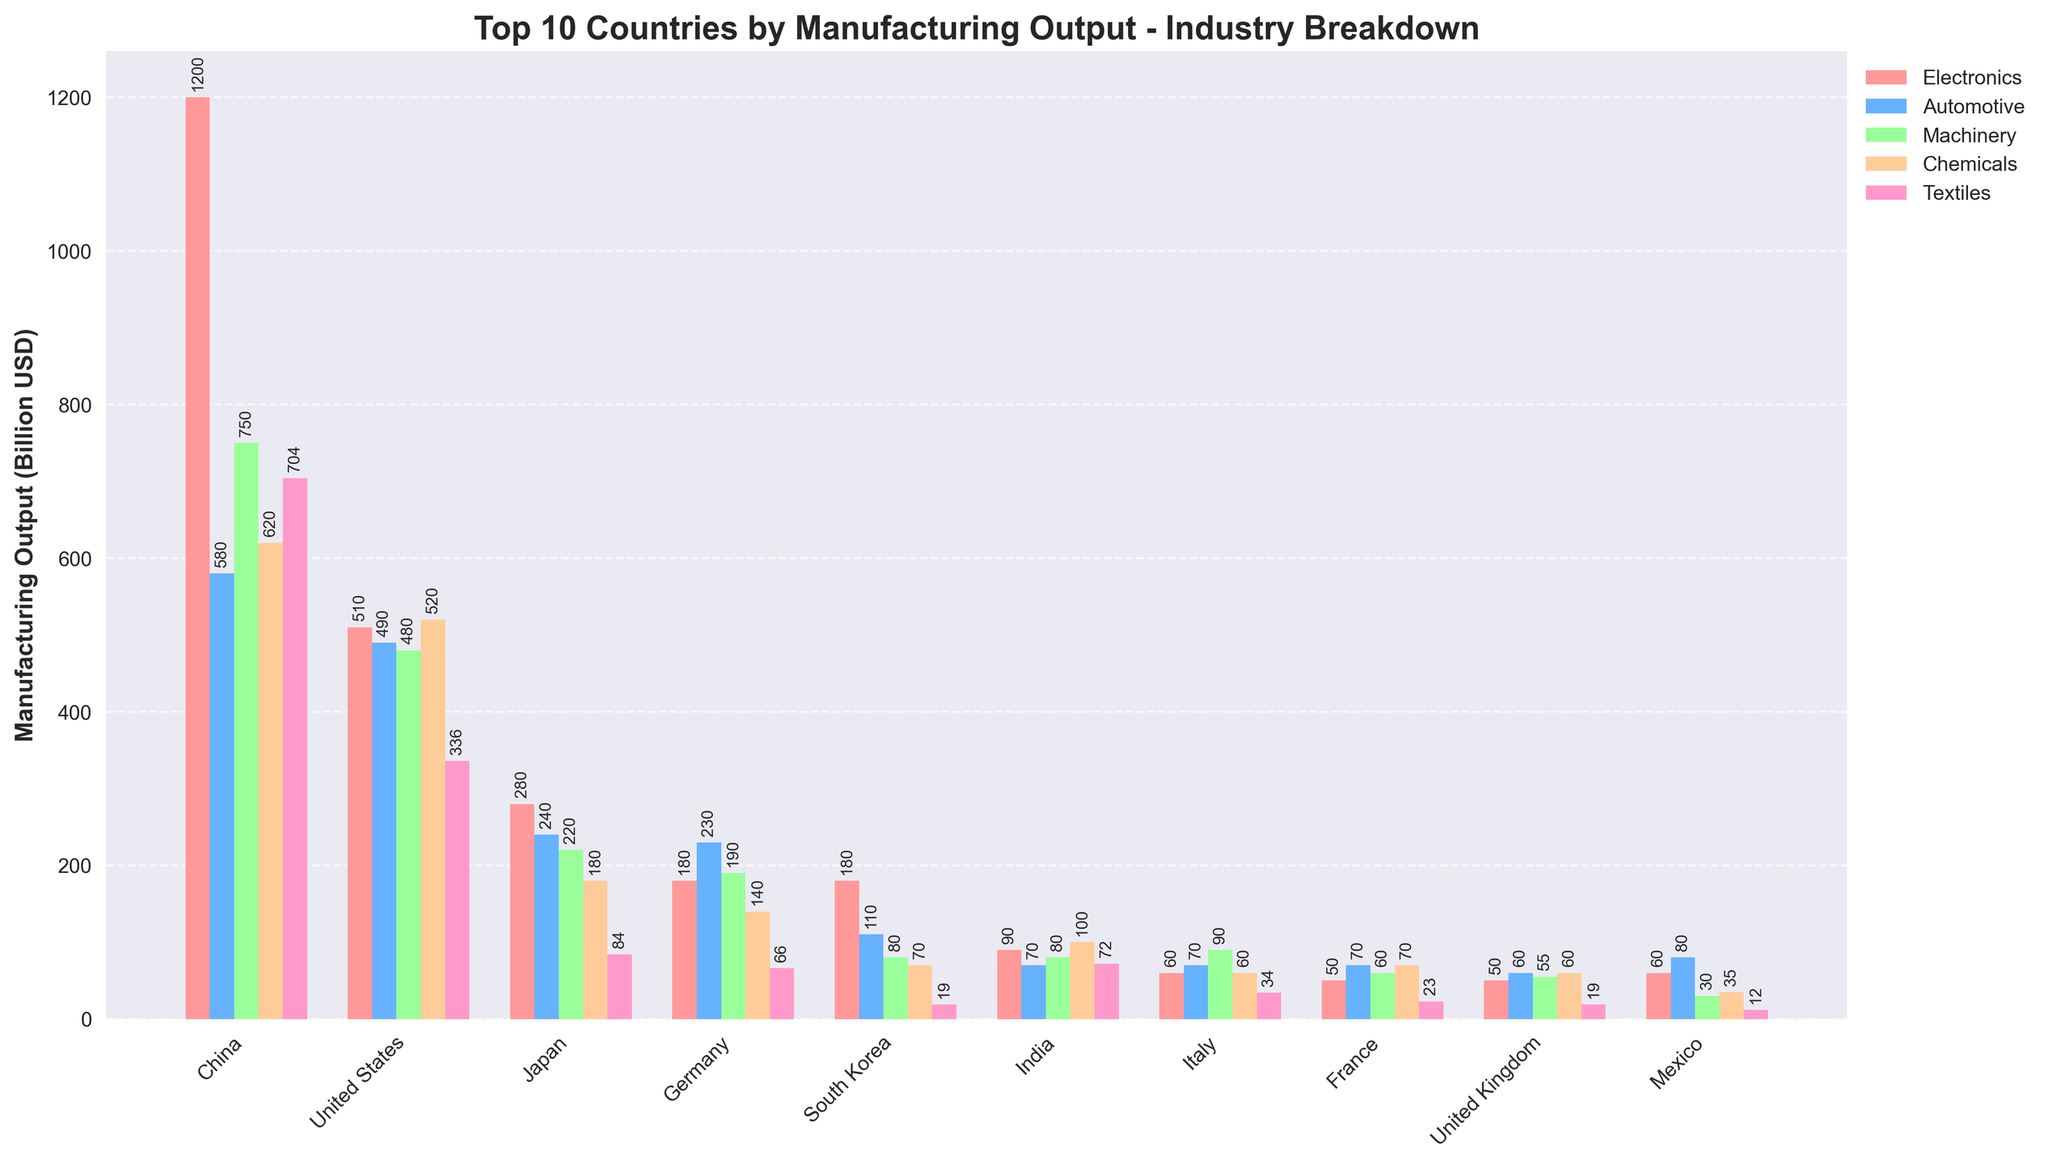What's the total manufacturing output of Japan in the Automotive and Machinery sectors combined? To find the total manufacturing output of Japan in the Automotive and Machinery sectors, add the values for Automotive (240 Billion USD) and Machinery (220 Billion USD). 240 + 220 = 460 Billion USD.
Answer: 460 Billion USD Which country has the highest manufacturing output in the Electronics sector? By examining the height of the bars in the Electronics sector for all countries, China has the highest bar with an output of 1200 Billion USD.
Answer: China How does the manufacturing output of Chemicals in Germany compare to that in France? Look at the bars for the Chemicals sector in Germany and France. Germany's bar is taller, indicating a higher manufacturing output. Germany’s output is 140 Billion USD, while France’s output is 70 Billion USD. 140 - 70 = 70 Billion USD, so Germany produces 70 Billion USD more in Chemicals than France.
Answer: Germany is 70 Billion USD higher What is the average manufacturing output in the Textiles sector across the top 10 countries? Sum the manufacturing outputs in Textiles for all countries: 704 (China) + 336 (USA) + 84 (Japan) + 66 (Germany) + 19 (South Korea) + 72 (India) + 34 (Italy) + 23 (France) + 19 (UK) + 12 (Mexico) = 1369 Billion USD. There are 10 countries; therefore, the average is 1369 / 10 = 136.9 Billion USD.
Answer: 136.9 Billion USD Which country has the lowest total manufacturing output, and what is that number? By inspecting the total height of all bars aggregated for each country, Mexico has the lowest total manufacturing output at 217 Billion USD.
Answer: Mexico, 217 Billion USD Is India's manufacturing output in the Electronics sector greater than South Korea’s output in the same sector? Compare the bars for Electronics in India (90 Billion USD) and South Korea (180 Billion USD). South Korea has a taller bar, indicating a greater manufacturing output.
Answer: No Which sector contributes the most to the United States' manufacturing output? Look at the tallest single bar for the United States, which is the Electronics sector with 510 Billion USD.
Answer: Electronics Between Italy and Mexico, which country has a higher total manufacturing output in the Automotive and Chemicals sectors combined? Italy’s Automotive (70 Billion USD) + Chemicals (60 Billion USD) = 130 Billion USD. Mexico’s Automotive (80 Billion USD) + Chemicals (35 Billion USD) = 115 Billion USD. Italy has a higher combined output (130 Billion USD) compared to Mexico (115 Billion USD).
Answer: Italy What is the total manufacturing output of China in the Electronics, Automotive, and Machinery sectors combined? Sum the outputs for Electronics (1200 Billion USD), Automotive (580 Billion USD), and Machinery (750 Billion USD) in China. 1200 + 580 + 750 = 2530 Billion USD.
Answer: 2530 Billion USD How does the Textile sector output of South Korea compare to that of the United Kingdom? Compare the bars for Textiles in South Korea and the United Kingdom. Both have an output of 19 Billion USD.
Answer: They are equal 